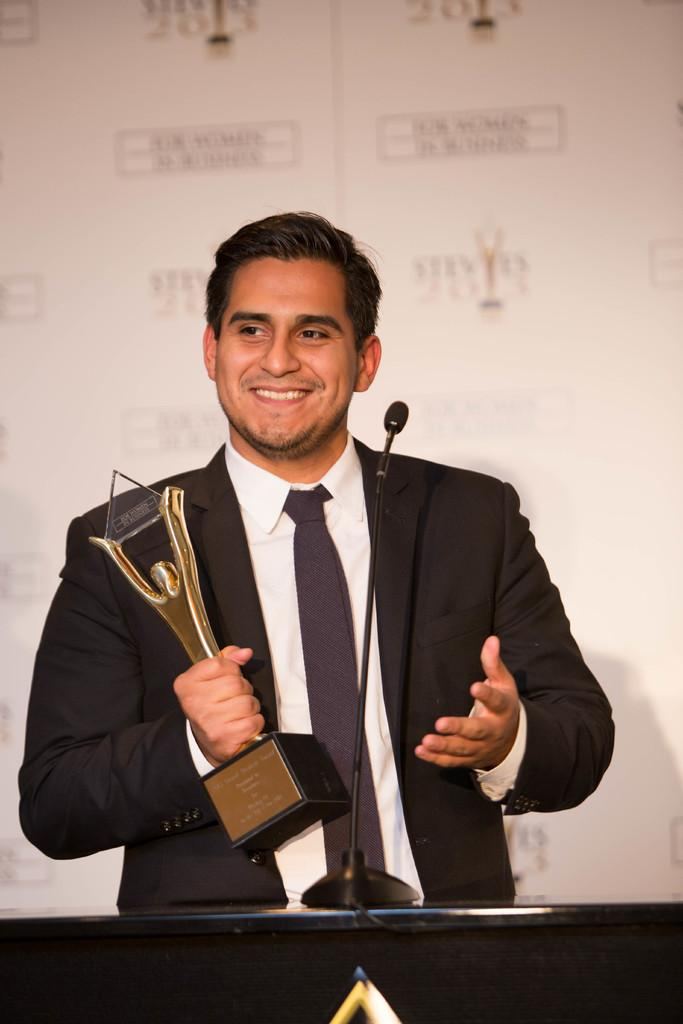What is the man in the image doing? The man is standing and holding an award in his hand. What is the man wearing in the image? The man is wearing a black coat, a white shirt, and a tie. What is the man's facial expression in the image? The man is smiling in the image. What is present in front of the man in the image? There is a podium in front of the man, and a microphone is present on the podium. What type of invention can be seen in the man's hand in the image? There is no invention visible in the man's hand in the image; he is holding an award. Can you tell me how many apples are on the podium in the image? There are no apples present on the podium in the image. 